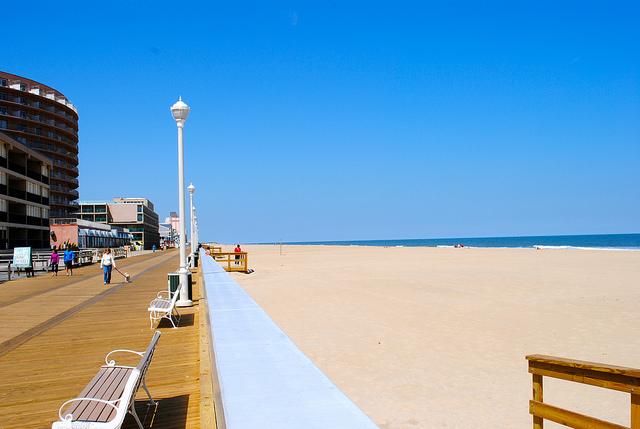What is the color of the sky?
Keep it brief. Blue. Where are the white metal benches facing?
Be succinct. Left. Is it a nice day?
Write a very short answer. Yes. 